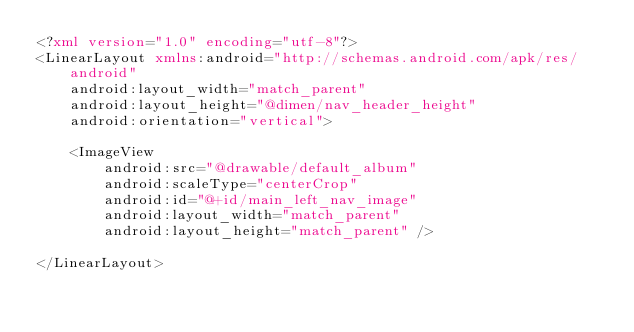Convert code to text. <code><loc_0><loc_0><loc_500><loc_500><_XML_><?xml version="1.0" encoding="utf-8"?>
<LinearLayout xmlns:android="http://schemas.android.com/apk/res/android"
    android:layout_width="match_parent"
    android:layout_height="@dimen/nav_header_height"
    android:orientation="vertical">

    <ImageView
        android:src="@drawable/default_album"
        android:scaleType="centerCrop"
        android:id="@+id/main_left_nav_image"
        android:layout_width="match_parent"
        android:layout_height="match_parent" />

</LinearLayout>
</code> 